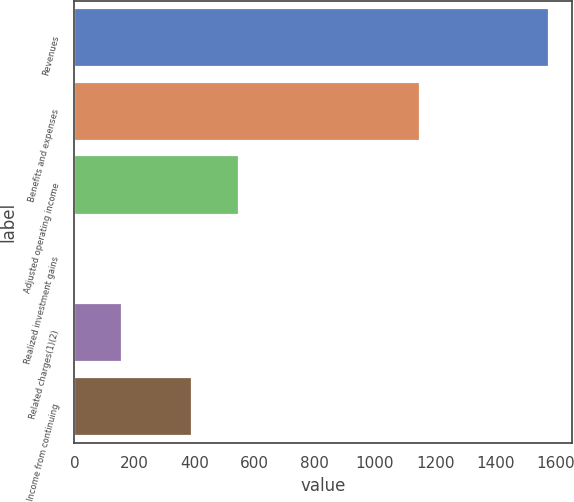<chart> <loc_0><loc_0><loc_500><loc_500><bar_chart><fcel>Revenues<fcel>Benefits and expenses<fcel>Adjusted operating income<fcel>Realized investment gains<fcel>Related charges(1)(2)<fcel>Income from continuing<nl><fcel>1578<fcel>1151<fcel>548.6<fcel>2<fcel>159.6<fcel>391<nl></chart> 